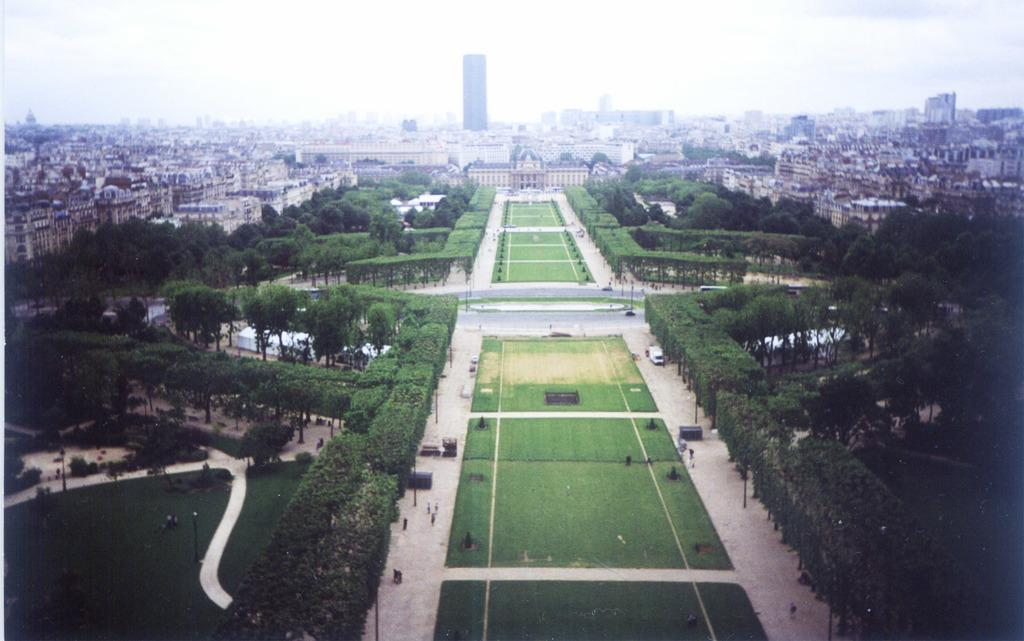What type of area is shown in the image? The image depicts a garden area. What can be seen on the left side of the image? There are plants on the left side of the image. What is located on the right side of the image? There are trees on the right side of the image. What can be seen in the background of the image? There are buildings and a clear sky visible in the background of the image. What type of friction can be seen between the plants and trees in the image? There is no friction between the plants and trees in the image; they are simply located next to each other. How does the image convey a sense of hate or animosity? The image does not convey a sense of hate or animosity; it is a peaceful garden scene. 